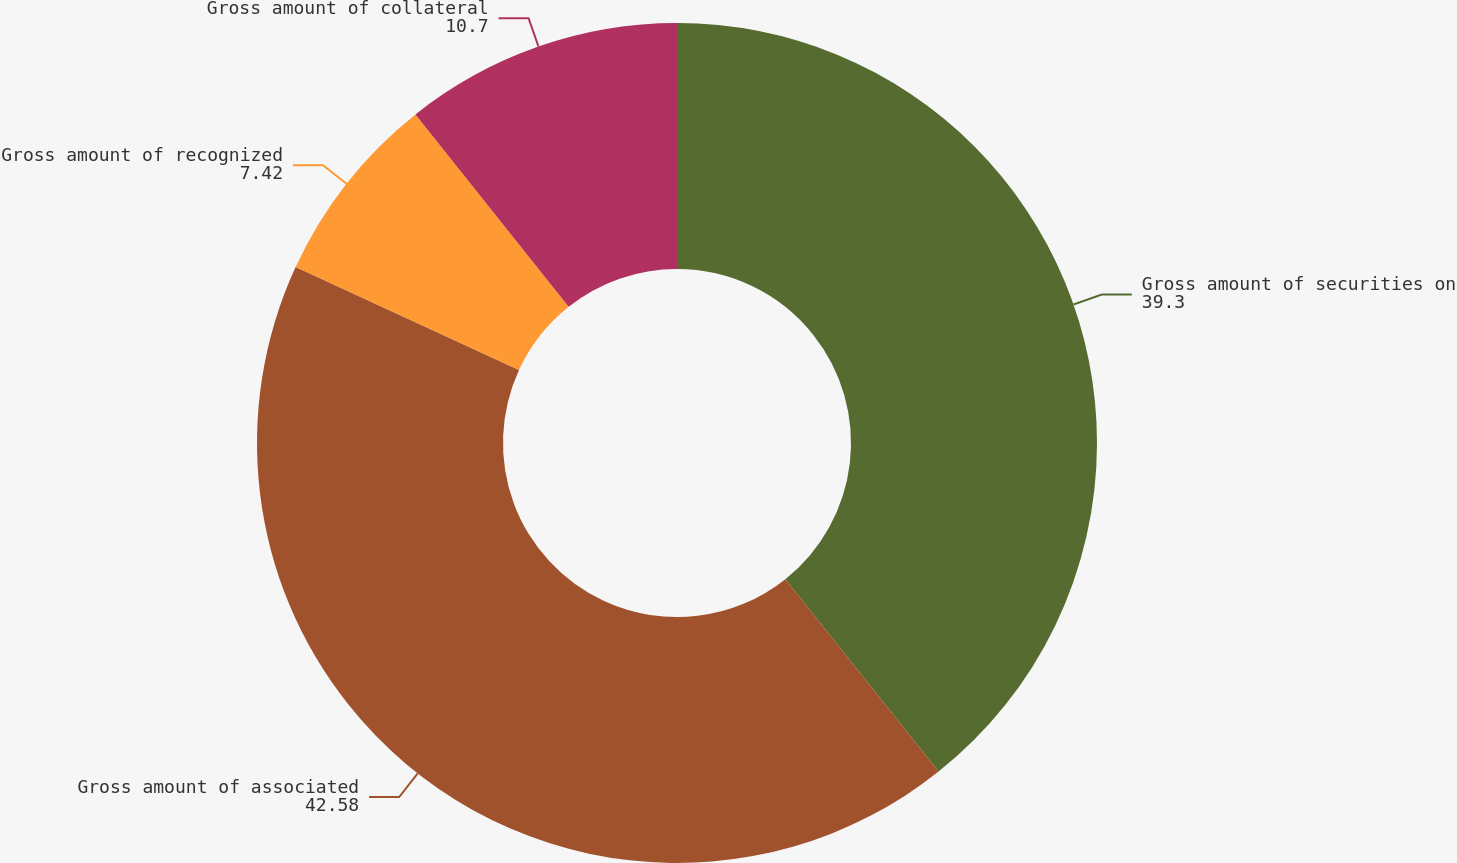Convert chart to OTSL. <chart><loc_0><loc_0><loc_500><loc_500><pie_chart><fcel>Gross amount of securities on<fcel>Gross amount of associated<fcel>Gross amount of recognized<fcel>Gross amount of collateral<nl><fcel>39.3%<fcel>42.58%<fcel>7.42%<fcel>10.7%<nl></chart> 